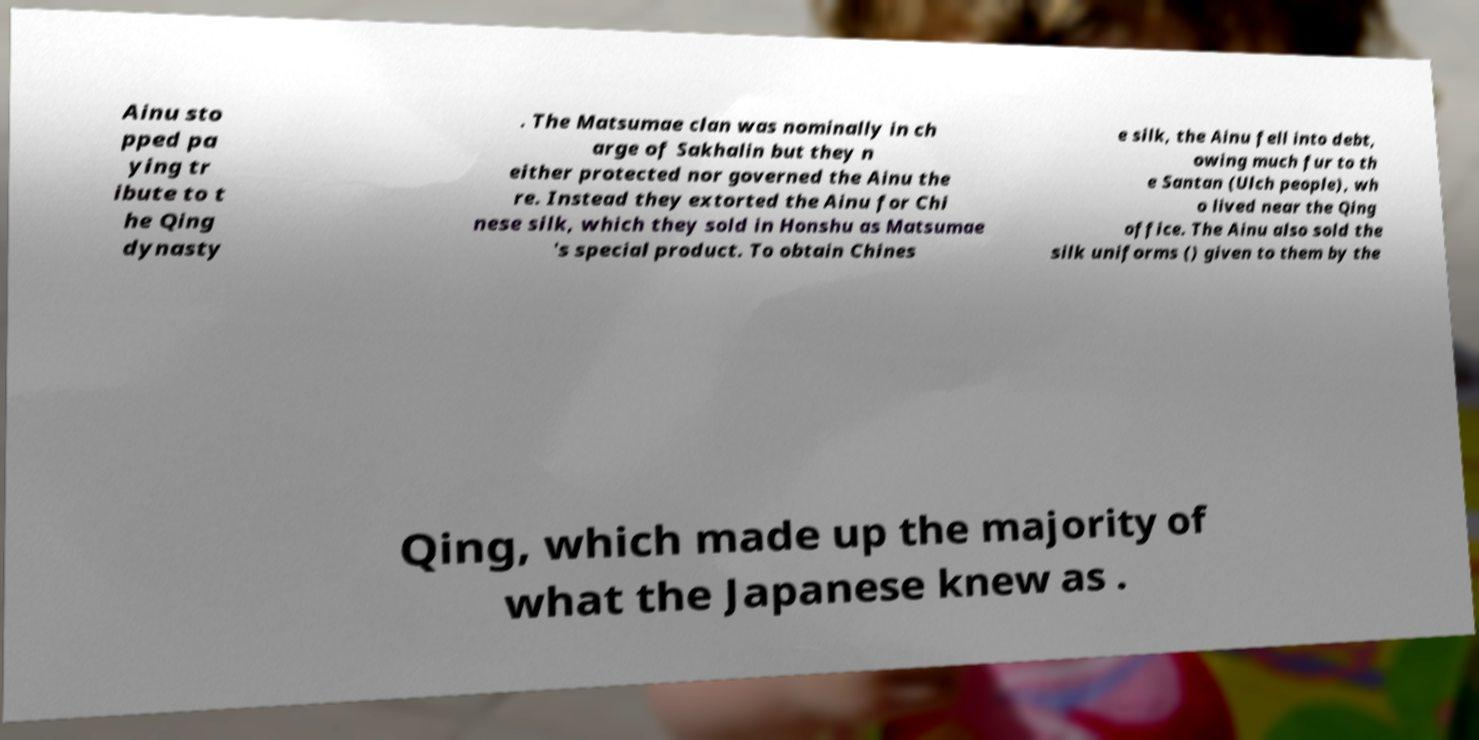Could you extract and type out the text from this image? Ainu sto pped pa ying tr ibute to t he Qing dynasty . The Matsumae clan was nominally in ch arge of Sakhalin but they n either protected nor governed the Ainu the re. Instead they extorted the Ainu for Chi nese silk, which they sold in Honshu as Matsumae 's special product. To obtain Chines e silk, the Ainu fell into debt, owing much fur to th e Santan (Ulch people), wh o lived near the Qing office. The Ainu also sold the silk uniforms () given to them by the Qing, which made up the majority of what the Japanese knew as . 